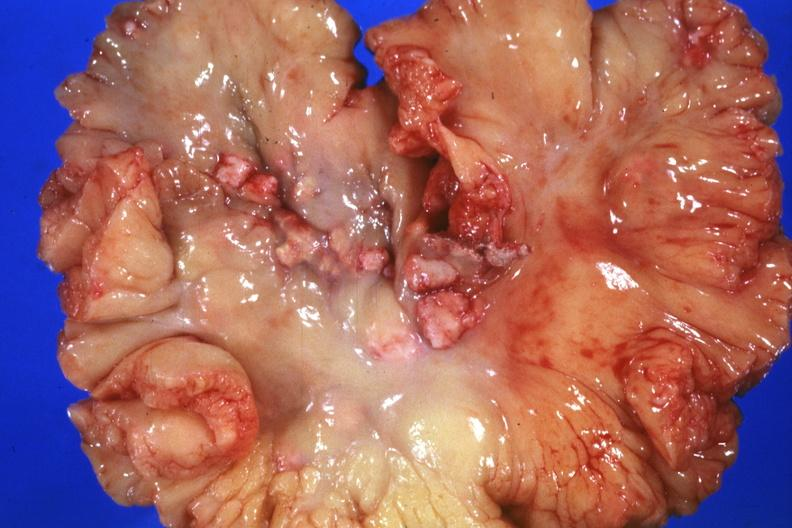what does this image show?
Answer the question using a single word or phrase. Mesentery with involved nodes 